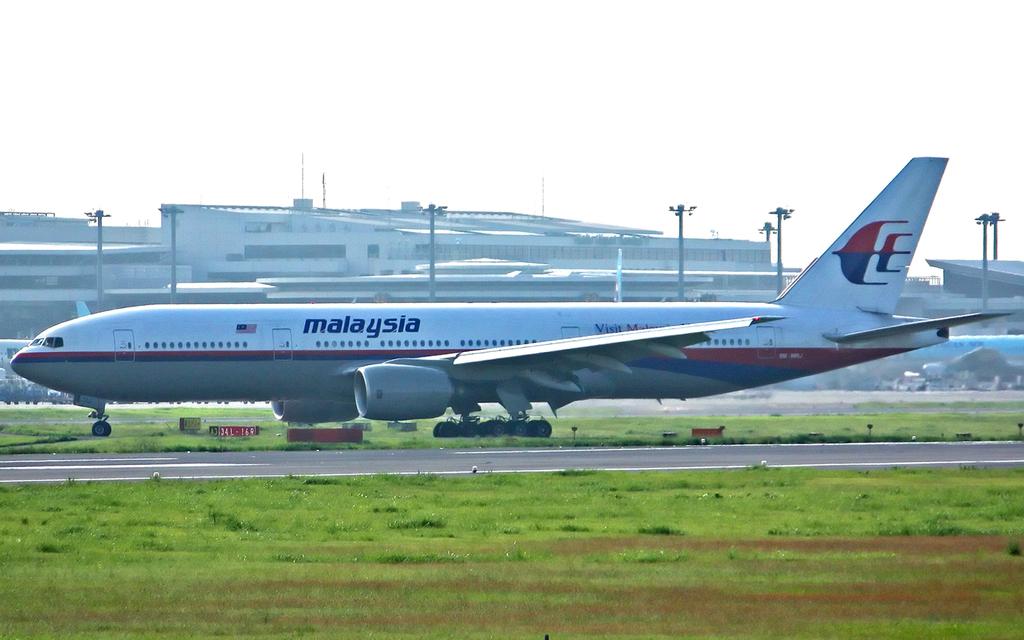What is the name of the airline of the plane?
Your answer should be compact. Malaysia. 